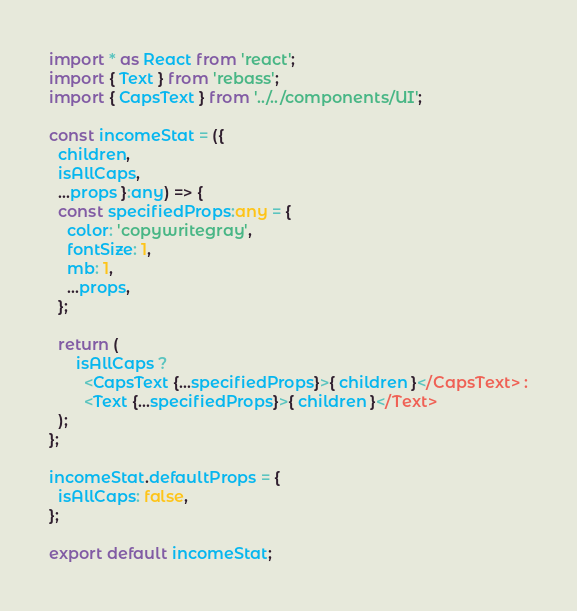Convert code to text. <code><loc_0><loc_0><loc_500><loc_500><_TypeScript_>import * as React from 'react';
import { Text } from 'rebass';
import { CapsText } from '../../components/UI';

const incomeStat = ({
  children,
  isAllCaps,
  ...props }:any) => {
  const specifiedProps:any = {
    color: 'copywritegray',
    fontSize: 1,
    mb: 1,
    ...props,
  };

  return (
      isAllCaps ?
        <CapsText {...specifiedProps}>{ children }</CapsText> :
        <Text {...specifiedProps}>{ children }</Text>
  );
};

incomeStat.defaultProps = {
  isAllCaps: false,
};

export default incomeStat;
</code> 